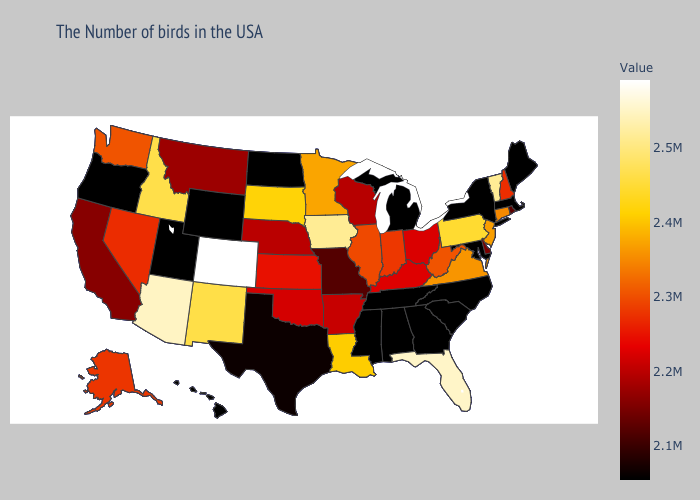Which states hav the highest value in the West?
Be succinct. Colorado. Does Missouri have the lowest value in the USA?
Write a very short answer. No. Does Kentucky have the lowest value in the South?
Write a very short answer. No. Which states have the lowest value in the South?
Short answer required. Maryland, North Carolina, South Carolina, Georgia, Alabama, Tennessee, Mississippi. Among the states that border Arizona , does Utah have the lowest value?
Quick response, please. Yes. 